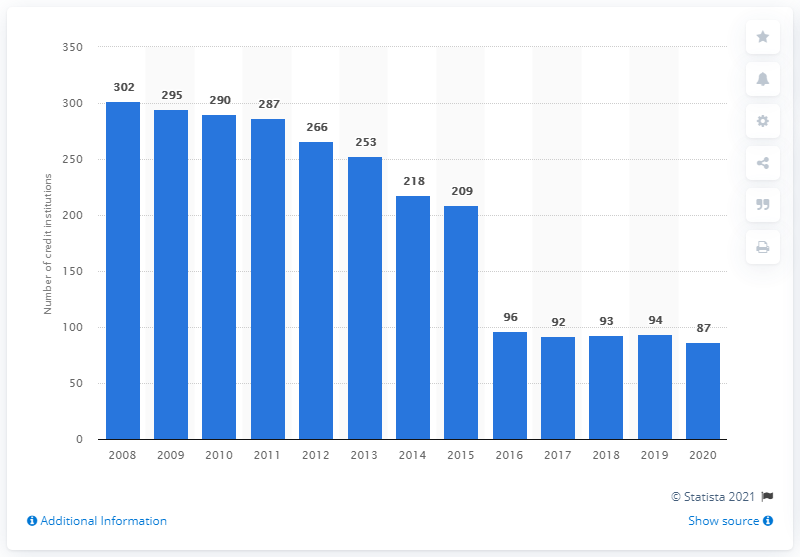Highlight a few significant elements in this photo. There were 87 Microfinance Institutions (MFIs) in the Netherlands at the end of 2020. 